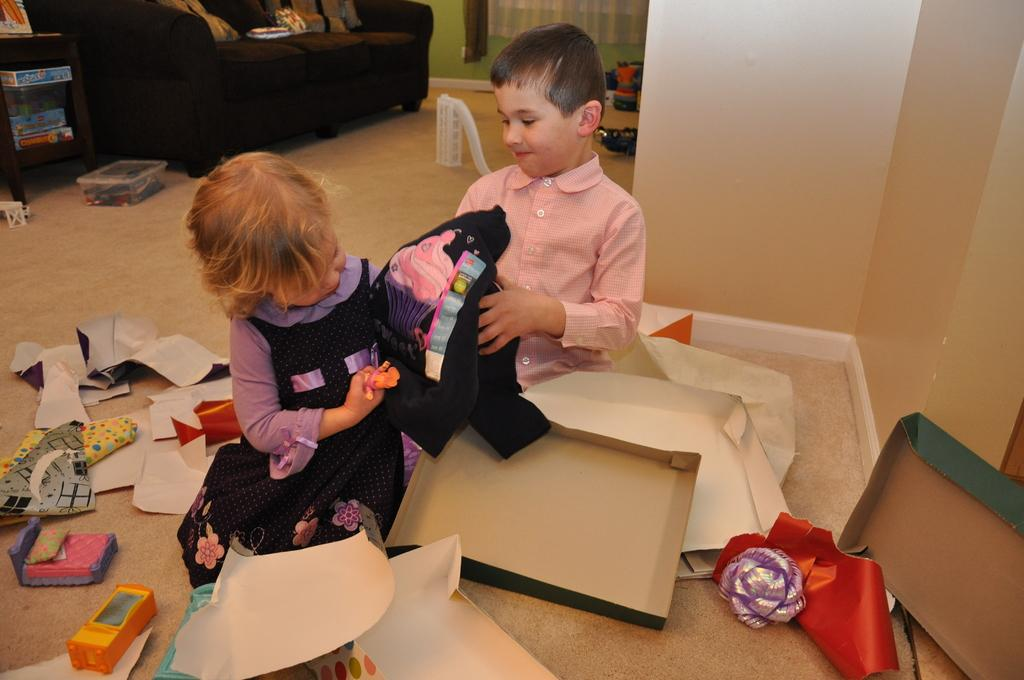How many people are in the image? There are two people in the image. What are the people doing in the image? The people are sitting on the floor and playing with papers and toys. What objects are the people playing with? The people are playing with papers and toys. Are there any toys visible in the image? Yes, there are toys present in the image. What type of cream is being used to lock the toys in the image? There is no cream or lock present in the image; the people are simply playing with toys and papers. 